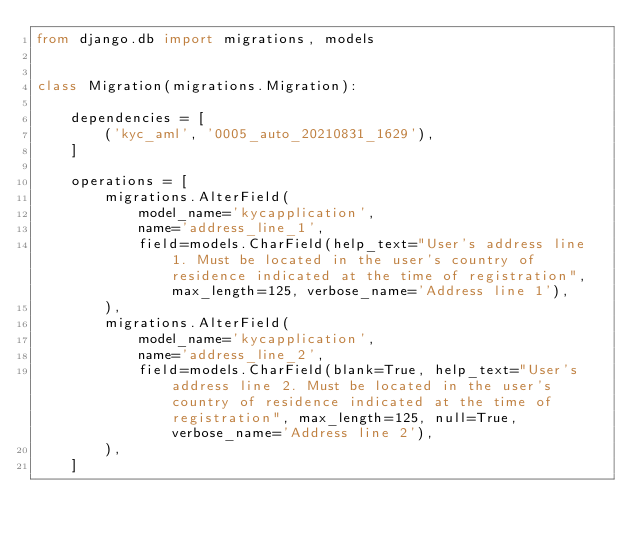Convert code to text. <code><loc_0><loc_0><loc_500><loc_500><_Python_>from django.db import migrations, models


class Migration(migrations.Migration):

    dependencies = [
        ('kyc_aml', '0005_auto_20210831_1629'),
    ]

    operations = [
        migrations.AlterField(
            model_name='kycapplication',
            name='address_line_1',
            field=models.CharField(help_text="User's address line 1. Must be located in the user's country of residence indicated at the time of registration", max_length=125, verbose_name='Address line 1'),
        ),
        migrations.AlterField(
            model_name='kycapplication',
            name='address_line_2',
            field=models.CharField(blank=True, help_text="User's address line 2. Must be located in the user's country of residence indicated at the time of registration", max_length=125, null=True, verbose_name='Address line 2'),
        ),
    ]
</code> 